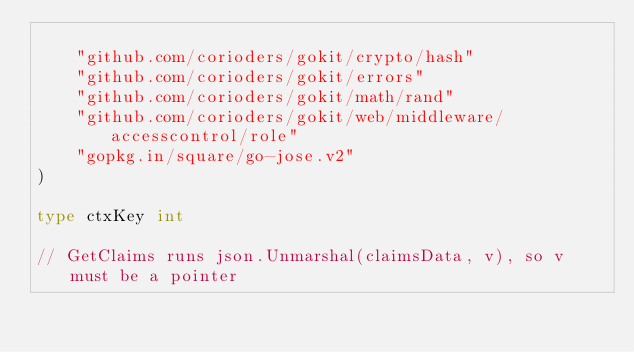Convert code to text. <code><loc_0><loc_0><loc_500><loc_500><_Go_>
	"github.com/corioders/gokit/crypto/hash"
	"github.com/corioders/gokit/errors"
	"github.com/corioders/gokit/math/rand"
	"github.com/corioders/gokit/web/middleware/accesscontrol/role"
	"gopkg.in/square/go-jose.v2"
)

type ctxKey int

// GetClaims runs json.Unmarshal(claimsData, v), so v must be a pointer</code> 